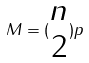<formula> <loc_0><loc_0><loc_500><loc_500>M = ( \begin{matrix} n \\ 2 \end{matrix} ) p</formula> 